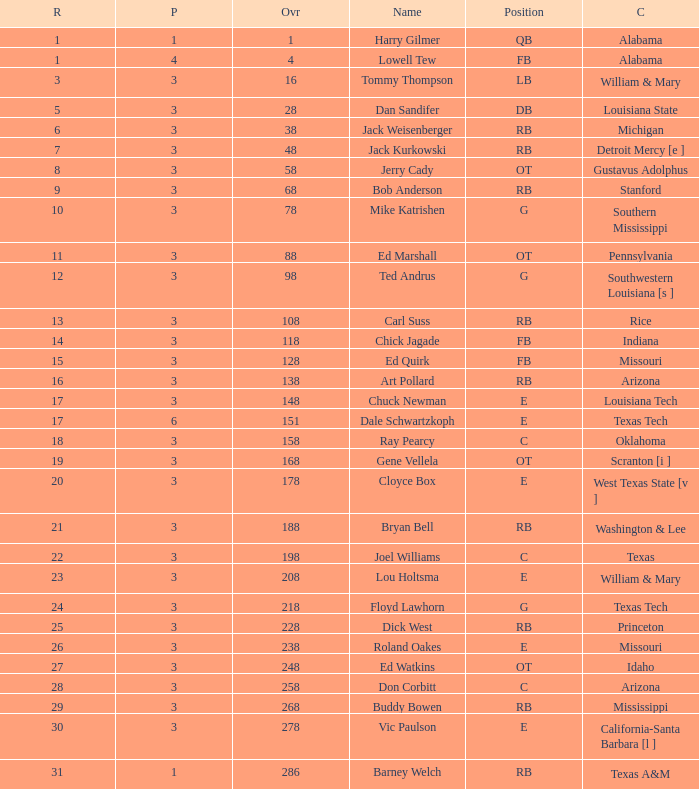How much Overall has a Name of bob anderson? 1.0. 